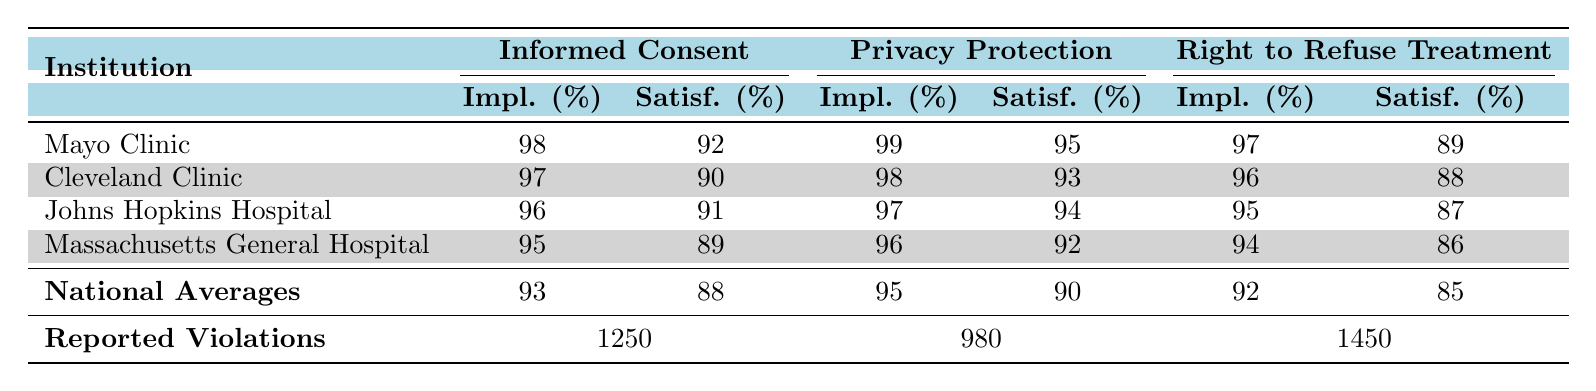What is the implementation rate for Informed Consent at Mayo Clinic? The table shows the implementation rate for Informed Consent at Mayo Clinic is listed as 98%.
Answer: 98% Which healthcare institution has the highest implementation rate for Privacy Protection? By examining the table, Mayo Clinic has the highest implementation rate for Privacy Protection at 99%.
Answer: Mayo Clinic What is the average patient satisfaction across all institutions for the Right to Refuse Treatment? To find the average, sum the patient satisfaction rates: (89 + 88 + 87 + 86) = 350. There are 4 institutions, so 350/4 = 87.5.
Answer: 87.5 Is the implementation rate for Right to Refuse Treatment at Cleveland Clinic above the national average? The implementation rate for Right to Refuse Treatment at Cleveland Clinic is 96%, while the national average is 92%. Since 96% is greater than 92%, the answer is yes.
Answer: Yes What is the total number of reported violations for Informed Consent and Right to Refuse Treatment combined? The reported violations for Informed Consent are 1250 and for Right to Refuse Treatment are 1450. Adding these together: 1250 + 1450 = 2700.
Answer: 2700 Which institution has the lowest patient satisfaction for Right to Refuse Treatment? Reviewing the table, Massachusetts General Hospital has the lowest patient satisfaction for Right to Refuse Treatment at 86%.
Answer: Massachusetts General Hospital What is the difference in implementation rates for Privacy Protection between Johns Hopkins Hospital and Massachusetts General Hospital? The implementation rate for Privacy Protection at Johns Hopkins Hospital is 97% and at Massachusetts General Hospital is 96%. The difference is calculated as 97% - 96% = 1%.
Answer: 1% Which institution has patient satisfaction for Informed Consent below the national average? The national average for patient satisfaction for Informed Consent is 88%. Massachusetts General Hospital has a patient satisfaction of 89%, Cleveland Clinic has 90%, Johns Hopkins Hospital has 91%, and Mayo Clinic has 92%. None has satisfaction below 88%, so the answer is no.
Answer: No What is the average implementation rate for all three policies across all institutions? To find the average implementation rate, we sum the implementation rates: (98 + 97 + 96 + 95 + 99 + 98 + 97 + 96 + 97 + 96 + 94 + 94) = 1150. There are 12 data points, so 1150/12 ≈ 95.83.
Answer: 95.83 How does patient satisfaction for Privacy Protection at Mayo Clinic compare to the national average? The patient satisfaction for Privacy Protection at Mayo Clinic is 95%, while the national average is 90%. Since 95% is greater than 90%, Mayo Clinic has a higher satisfaction level.
Answer: Higher 